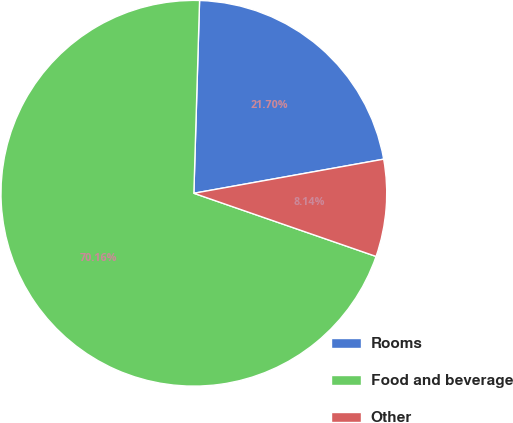<chart> <loc_0><loc_0><loc_500><loc_500><pie_chart><fcel>Rooms<fcel>Food and beverage<fcel>Other<nl><fcel>21.7%<fcel>70.16%<fcel>8.14%<nl></chart> 